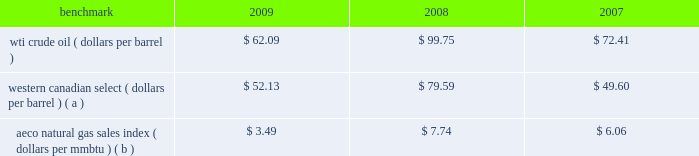Natural gas prices on average were lower in 2009 than in 2008 and in 2007 , with prices in 2008 hitting uniquely high levels .
A significant portion of our natural gas production in the lower 48 states of the u.s .
Is sold at bid-week prices or first-of-month indices relative to our specific producing areas .
A large portion of natural gas sales in alaska are subject to term contracts .
Our other major natural gas-producing regions are europe and equatorial guinea , where large portions of our natural gas sales are also subject to term contracts , making realized prices in these areas less volatile .
As we sell larger quantities of natural gas from these regions , to the extent that these fixed prices are lower than prevailing prices , our reported average natural gas prices realizations may be less than benchmark natural gas prices .
Oil sands mining oil sands mining segment revenues correlate with prevailing market prices for the various qualities of synthetic crude oil and vacuum gas oil we produce .
Roughly two-thirds of the normal output mix will track movements in wti and one-third will track movements in the canadian heavy sour crude oil marker , primarily western canadian select .
Output mix can be impacted by operational problems or planned unit outages at the mine or the upgrader .
The operating cost structure of the oil sands mining operations is predominantly fixed and therefore many of the costs incurred in times of full operation continue during production downtime .
Per-unit costs are sensitive to production rates .
Key variable costs are natural gas and diesel fuel , which track commodity markets such as the canadian aeco natural gas sales index and crude prices respectively .
The table below shows average benchmark prices that impact both our revenues and variable costs. .
Western canadian select ( dollars per barrel ) ( a ) $ 52.13 $ 79.59 $ 49.60 aeco natural gas sales index ( dollars per mmbtu ) ( b ) $ 3.49 $ 7.74 $ 6.06 ( a ) monthly pricing based upon average wti adjusted for differentials unique to western canada .
( b ) alberta energy company day ahead index .
Integrated gas our integrated gas strategy is to link stranded natural gas resources with areas where a supply gap is emerging due to declining production and growing demand .
Our integrated gas operations include marketing and transportation of products manufactured from natural gas , such as lng and methanol , primarily in west africa , the u.s .
And europe .
Our most significant lng investment is our 60 percent ownership in a production facility in equatorial guinea , which sells lng under a long-term contract at prices tied to henry hub natural gas prices .
In 2009 , the gross sales from the plant were 3.9 million metric tonnes , while in 2008 , its first full year of operations , the plant sold 3.4 million metric tonnes .
Industry estimates of 2009 lng trade are approximately 185 million metric tonnes .
More lng production facilities and tankers were under construction in 2009 .
As a result of the sharp worldwide economic downturn in 2008 , continued weak economies are expected to lower natural gas consumption in various countries ; therefore , affecting near-term demand for lng .
Long-term lng supply continues to be in demand as markets seek the benefits of clean burning natural gas .
Market prices for lng are not reported or posted .
In general , lng delivered to the u.s .
Is tied to henry hub prices and will track with changes in u.s .
Natural gas prices , while lng sold in europe and asia is indexed to crude oil prices and will track the movement of those prices .
We own a 45 percent interest in a methanol plant located in equatorial guinea through our investment in ampco .
Gross sales of methanol from the plant totaled 960374 metric tonnes in 2009 and 792794 metric tonnes in 2008 .
Methanol demand has a direct impact on ampco 2019s earnings .
Because global demand for methanol is rather limited , changes in the supply-demand balance can have a significant impact on sales prices .
The 2010 chemical markets associates , inc .
Estimates world demand for methanol in 2009 was 41 million metric tonnes .
Our plant capacity is 1.1 million , or about 3 percent of total demand .
Refining , marketing and transportation rm&t segment income depends largely on our refining and wholesale marketing gross margin , refinery throughputs and retail marketing gross margins for gasoline , distillates and merchandise. .
By what percentage did the average price of the wti crude oil benchmark decrease from 2008 to 2009? 
Computations: ((62.09 - 99.75) / 99.75)
Answer: -0.37754. 